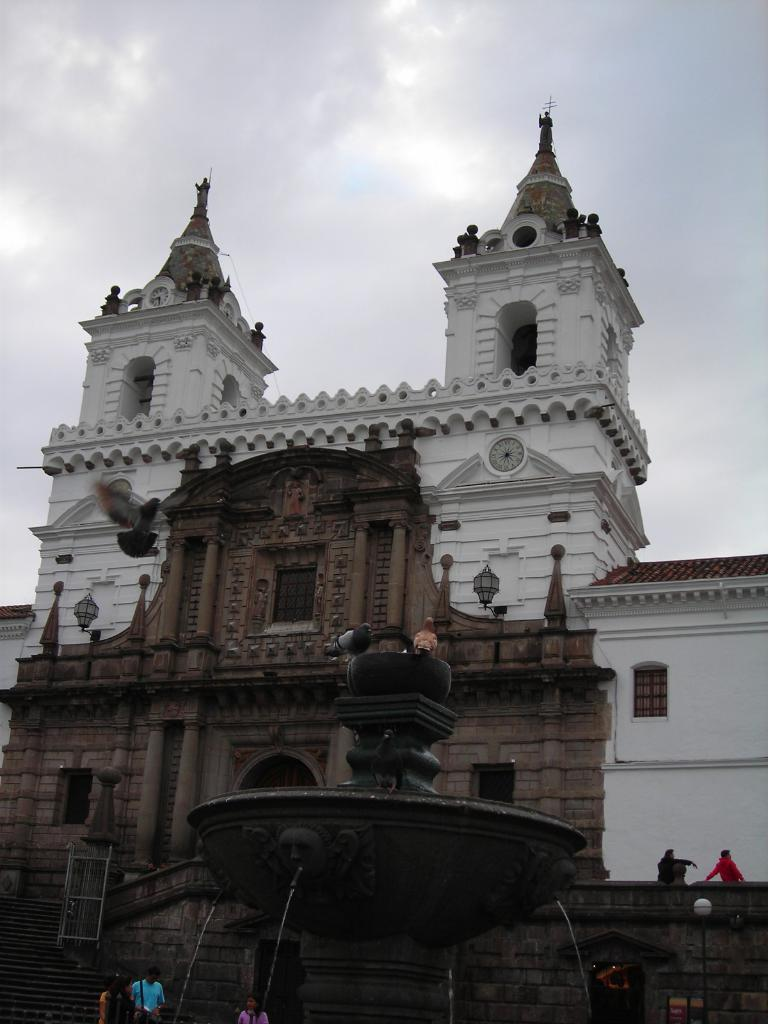What type of structures can be seen in the image? There are buildings in the image. Are there any living beings present in the image? Yes, there are people in the image. What is the focal point of the image? There appears to be a fountain in the image. What is on top of the fountain? There are birds on the fountain. How would you describe the weather in the image? The sky is cloudy in the image. What type of punishment is being handed out in the image? There is no indication of punishment in the image; it features buildings, people, a fountain, birds, and a cloudy sky. What kind of art is displayed on the buildings in the image? The provided facts do not mention any specific art on the buildings, so we cannot determine if any art is displayed. 